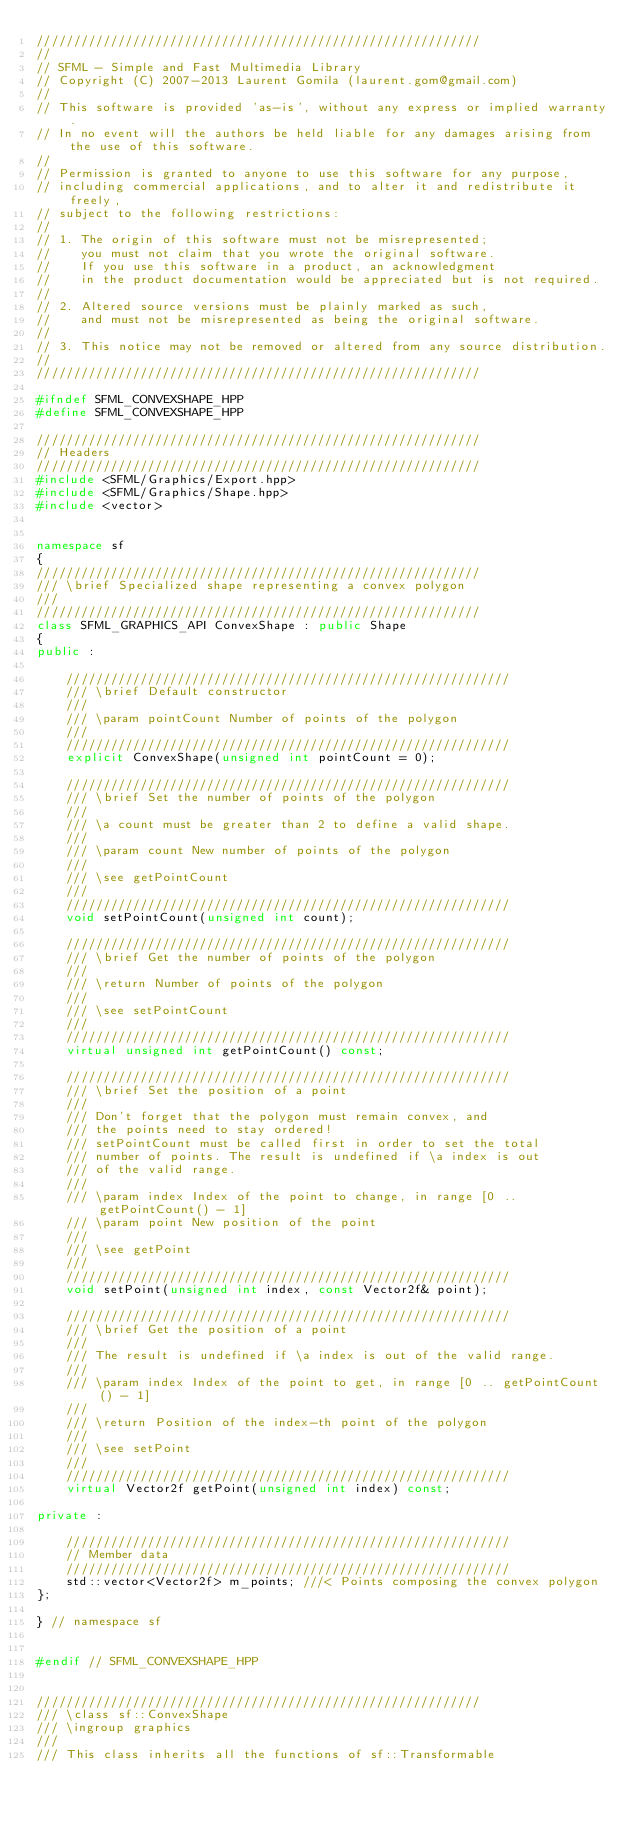<code> <loc_0><loc_0><loc_500><loc_500><_C++_>////////////////////////////////////////////////////////////
//
// SFML - Simple and Fast Multimedia Library
// Copyright (C) 2007-2013 Laurent Gomila (laurent.gom@gmail.com)
//
// This software is provided 'as-is', without any express or implied warranty.
// In no event will the authors be held liable for any damages arising from the use of this software.
//
// Permission is granted to anyone to use this software for any purpose,
// including commercial applications, and to alter it and redistribute it freely,
// subject to the following restrictions:
//
// 1. The origin of this software must not be misrepresented;
//    you must not claim that you wrote the original software.
//    If you use this software in a product, an acknowledgment
//    in the product documentation would be appreciated but is not required.
//
// 2. Altered source versions must be plainly marked as such,
//    and must not be misrepresented as being the original software.
//
// 3. This notice may not be removed or altered from any source distribution.
//
////////////////////////////////////////////////////////////

#ifndef SFML_CONVEXSHAPE_HPP
#define SFML_CONVEXSHAPE_HPP

////////////////////////////////////////////////////////////
// Headers
////////////////////////////////////////////////////////////
#include <SFML/Graphics/Export.hpp>
#include <SFML/Graphics/Shape.hpp>
#include <vector>


namespace sf
{
////////////////////////////////////////////////////////////
/// \brief Specialized shape representing a convex polygon
///
////////////////////////////////////////////////////////////
class SFML_GRAPHICS_API ConvexShape : public Shape
{
public :

    ////////////////////////////////////////////////////////////
    /// \brief Default constructor
    ///
    /// \param pointCount Number of points of the polygon
    ///
    ////////////////////////////////////////////////////////////
    explicit ConvexShape(unsigned int pointCount = 0);

    ////////////////////////////////////////////////////////////
    /// \brief Set the number of points of the polygon
    ///
    /// \a count must be greater than 2 to define a valid shape.
    ///
    /// \param count New number of points of the polygon
    ///
    /// \see getPointCount
    ///
    ////////////////////////////////////////////////////////////
    void setPointCount(unsigned int count);

    ////////////////////////////////////////////////////////////
    /// \brief Get the number of points of the polygon
    ///
    /// \return Number of points of the polygon
    ///
    /// \see setPointCount
    ///
    ////////////////////////////////////////////////////////////
    virtual unsigned int getPointCount() const;

    ////////////////////////////////////////////////////////////
    /// \brief Set the position of a point
    ///
    /// Don't forget that the polygon must remain convex, and
    /// the points need to stay ordered!
    /// setPointCount must be called first in order to set the total
    /// number of points. The result is undefined if \a index is out
    /// of the valid range.
    ///
    /// \param index Index of the point to change, in range [0 .. getPointCount() - 1]
    /// \param point New position of the point
    ///
    /// \see getPoint
    ///
    ////////////////////////////////////////////////////////////
    void setPoint(unsigned int index, const Vector2f& point);

    ////////////////////////////////////////////////////////////
    /// \brief Get the position of a point
    ///
    /// The result is undefined if \a index is out of the valid range.
    ///
    /// \param index Index of the point to get, in range [0 .. getPointCount() - 1]
    ///
    /// \return Position of the index-th point of the polygon
    ///
    /// \see setPoint
    ///
    ////////////////////////////////////////////////////////////
    virtual Vector2f getPoint(unsigned int index) const;

private :

    ////////////////////////////////////////////////////////////
    // Member data
    ////////////////////////////////////////////////////////////
    std::vector<Vector2f> m_points; ///< Points composing the convex polygon
};

} // namespace sf


#endif // SFML_CONVEXSHAPE_HPP


////////////////////////////////////////////////////////////
/// \class sf::ConvexShape
/// \ingroup graphics
///
/// This class inherits all the functions of sf::Transformable</code> 